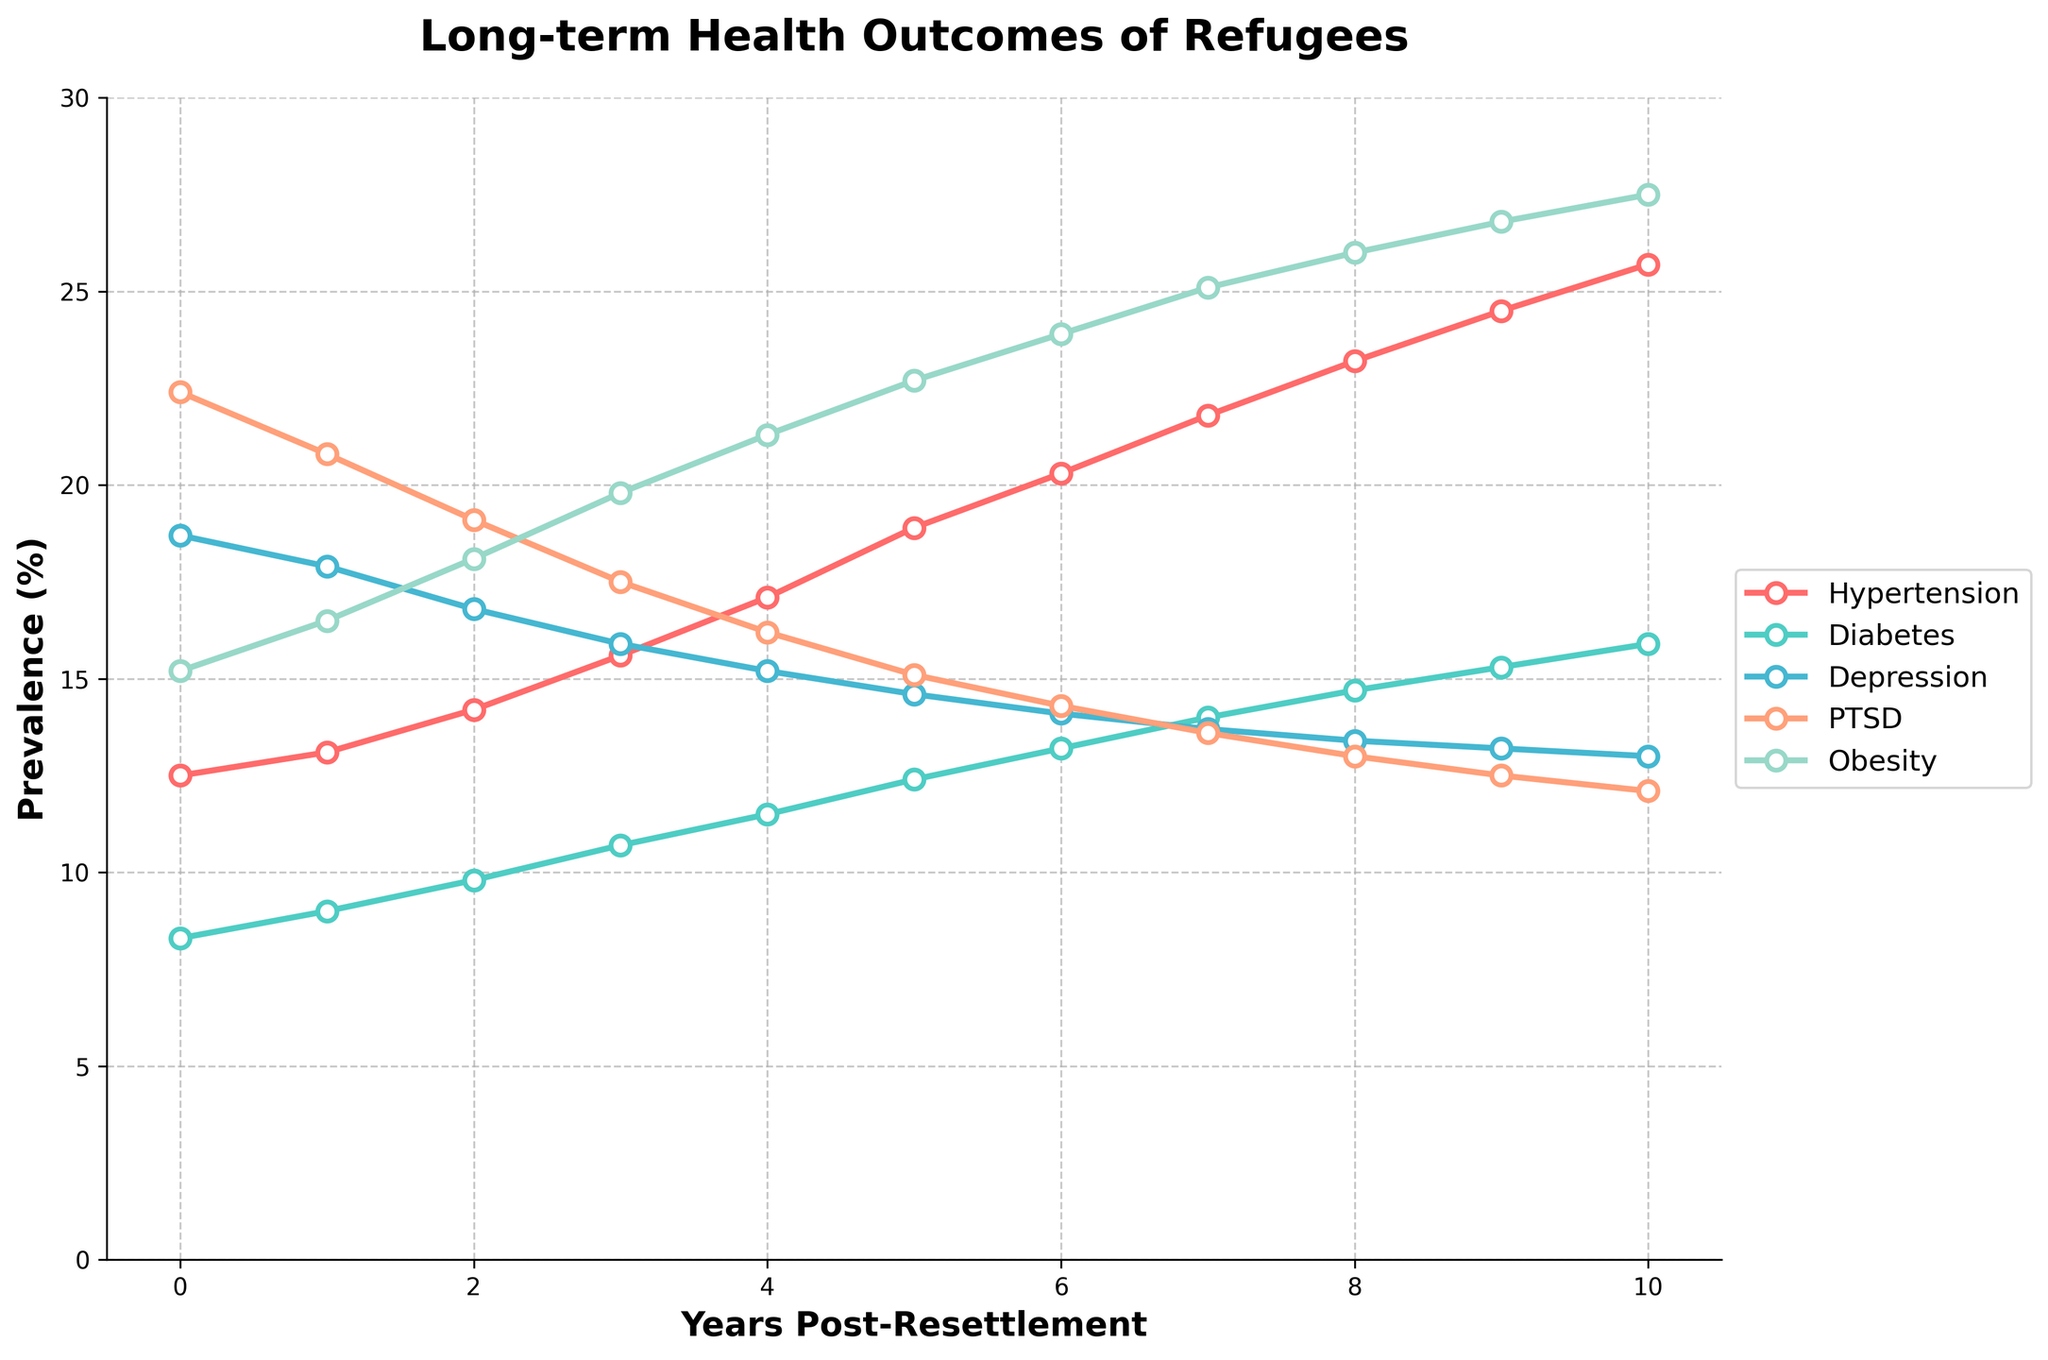Which health condition shows the highest rate at 10 years post-resettlement? The highest rate at 10 years post-resettlement can be found by comparing the values of all conditions at Year 10. Hypertension is at 25.7%, Diabetes at 15.9%, Depression at 13.0%, PTSD at 12.1%, and Obesity at 27.5%. Obesity has the highest rate.
Answer: Obesity How has the prevalence of PTSD changed from arrival to 10 years post-resettlement? Examine the PTSD percentages at Year 0 and Year 10. At Year 0, PTSD is 22.4%. At Year 10, PTSD is 12.1%. The change is 12.1% - 22.4% = -10.3%. The prevalence has decreased by 10.3%.
Answer: Decreased by 10.3% Which health condition has shown the most significant overall increase in prevalence from arrival to 10 years post-resettlement? To find this, compute the change for each condition from Year 0 to Year 10. For Hypertension: 25.7% - 12.5% = 13.2%, Diabetes: 15.9% - 8.3% = 7.6%, Depression: 13.0% - 18.7% = -5.7%, PTSD: 12.1% - 22.4% = -10.3%, Obesity: 27.5% - 15.2% = 12.3%. Hypertension has the highest increase of 13.2%.
Answer: Hypertension At what year does Depression have the same prevalence as PTSD? Look for the year where the Depression and PTSD lines intersect or have the same value. Checking each year: Year 6 has Depression at 14.1% and PTSD at 14.3%, Year 7 has Depression at 13.7% and PTSD at 13.6%. They are closest at Year 7 (13.7% vs 13.6%).
Answer: Year 7 Compare the prevalence of Diabetes and Hypertension at 5 years post-resettlement. Which condition is more prevalent? At Year 5, compare the values: Diabetes is 12.4%, Hypertension is 18.9%. Hypertension is more prevalent.
Answer: Hypertension What is the total change in prevalence for Obesity over 10 years? Compute the change in prevalence for Obesity from Year 0 to Year 10. Year 0 is 15.2%, Year 10 is 27.5%. Change is 27.5% - 15.2% = 12.3%.
Answer: 12.3% In which year is the prevalence of Depression the lowest? Check the values for Depression across all years. The lowest value is at Year 10 with 13.0%.
Answer: Year 10 Is there any health condition that shows a decrease in prevalence from Year 0 to Year 10? Compare the percentages from Year 0 to Year 10 for each condition. Depression (18.7% to 13.0%) and PTSD (22.4% to 12.1%) both show a decrease.
Answer: Depression, PTSD What is the average prevalence of Diabetes over the 10 years? Calculate the average of Diabetes percentages from Year 0 to Year 10. (8.3% + 9.0% + 9.8% + 10.7% + 11.5% + 12.4% + 13.2% + 14.0% + 14.7% + 15.3% + 15.9%) / 11 = 11.97%
Answer: 11.97% How does the trend in Hypertension prevalence compare to that of PTSD over the 10 years? Hypertension shows a consistent increase from 12.5% to 25.7%. PTSD shows a consistent decrease from 22.4% to 12.1%.
Answer: Hypertension increases, PTSD decreases 